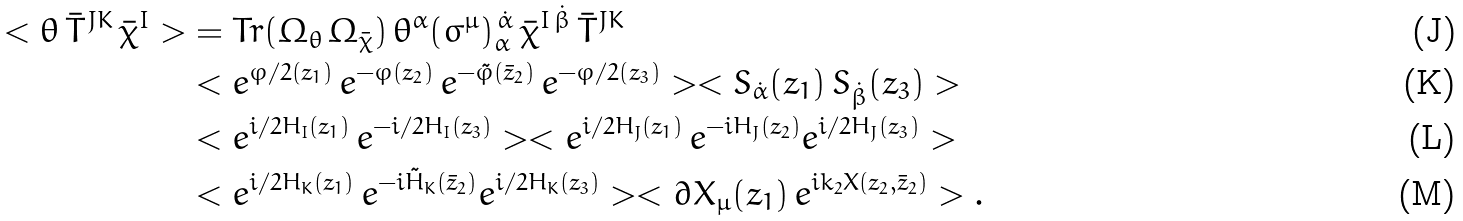Convert formula to latex. <formula><loc_0><loc_0><loc_500><loc_500>< \theta \, \bar { T } ^ { J K } \, \bar { \chi } ^ { I } > & = T r ( \Omega _ { \theta } \, \Omega _ { \bar { \chi } } ) \, \theta ^ { \alpha } ( \sigma ^ { \mu } ) ^ { \, \dot { \alpha } } _ { \alpha \, } \, \bar { \chi } ^ { I \, \dot { \beta } } \, \bar { T } ^ { J K } \\ & < e ^ { \varphi / 2 ( z _ { 1 } ) } \, e ^ { - \varphi ( z _ { 2 } ) } \, e ^ { - \tilde { \varphi } ( \bar { z } _ { 2 } ) } \, e ^ { - \varphi / 2 ( z _ { 3 } ) } > < S _ { \dot { \alpha } } ( z _ { 1 } ) \, S _ { \dot { \beta } } ( z _ { 3 } ) > \\ & < e ^ { i / 2 H _ { I } ( z _ { 1 } ) } \, e ^ { - i / 2 H _ { I } ( z _ { 3 } ) } > < e ^ { i / 2 H _ { J } ( z _ { 1 } ) } \, e ^ { - i H _ { J } ( z _ { 2 } ) } e ^ { i / 2 H _ { J } ( z _ { 3 } ) } > \\ & < e ^ { i / 2 H _ { K } ( z _ { 1 } ) } \, e ^ { - i \tilde { H } _ { K } ( \bar { z } _ { 2 } ) } e ^ { i / 2 H _ { K } ( z _ { 3 } ) } > < \partial X _ { \mu } ( z _ { 1 } ) \, e ^ { i k _ { 2 } X ( z _ { 2 } , \bar { z } _ { 2 } ) } > .</formula> 